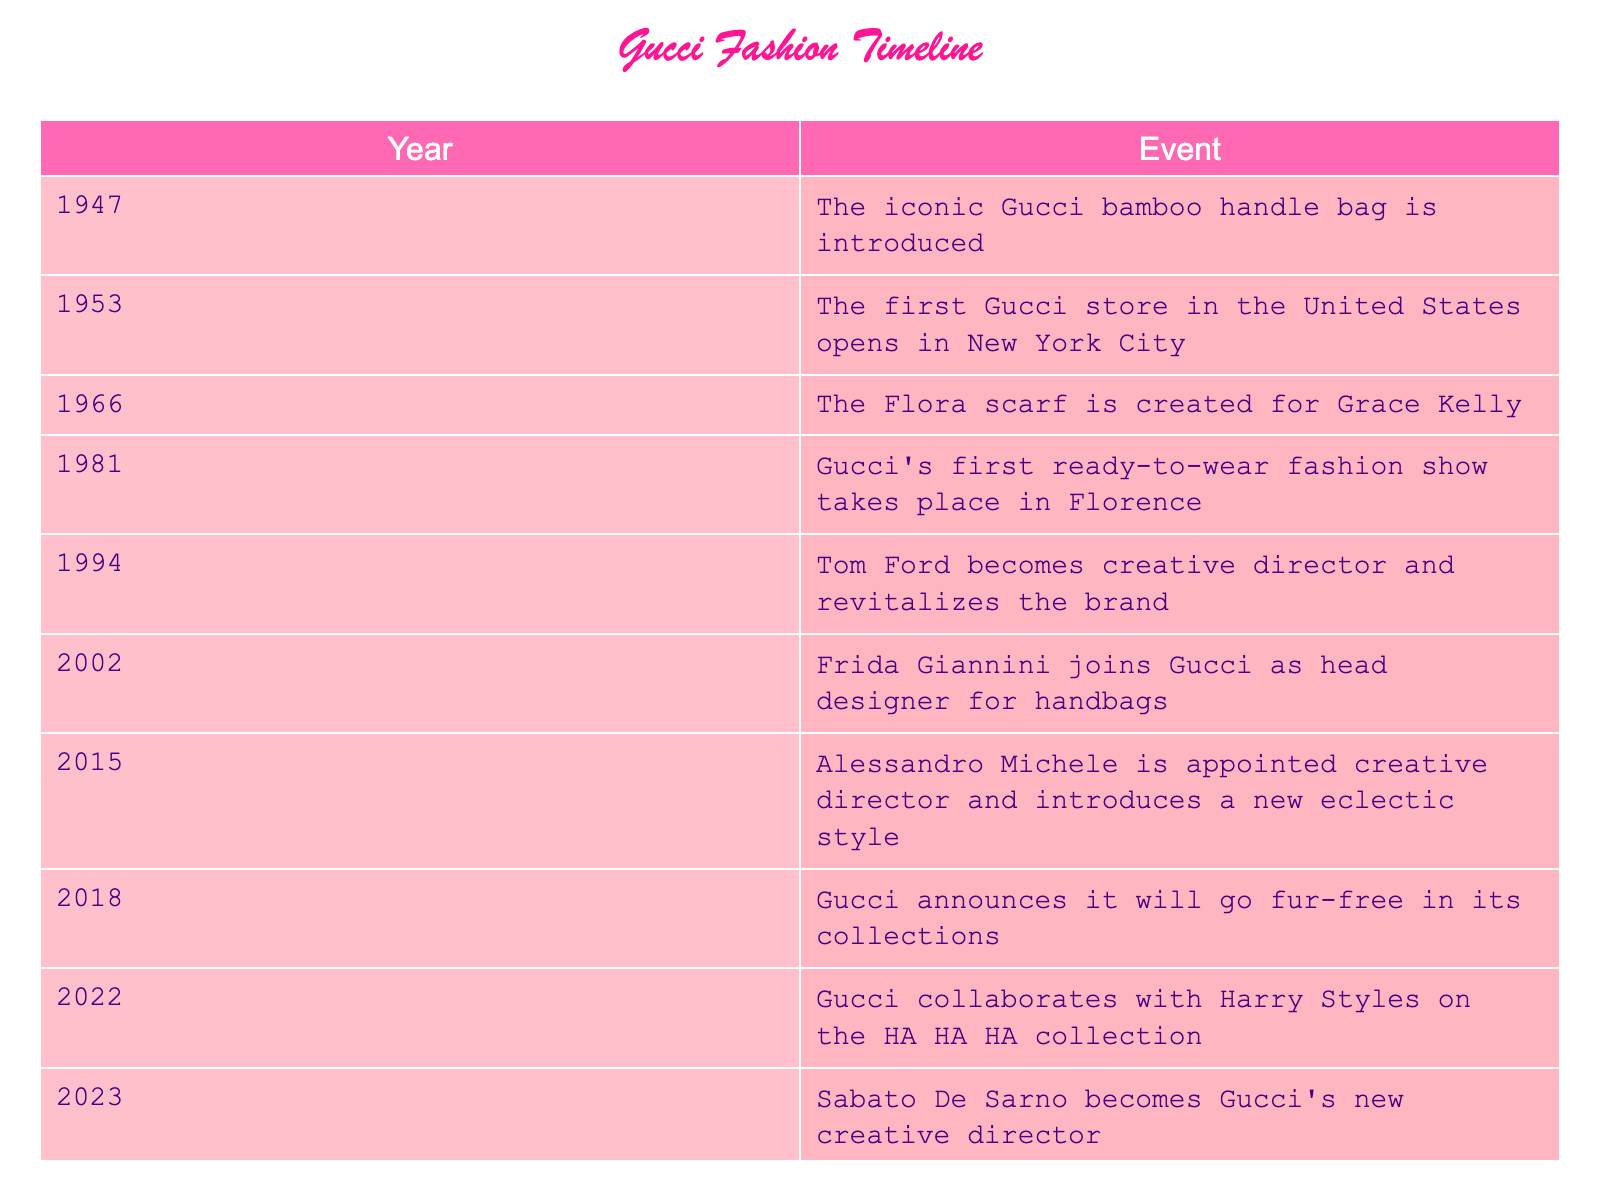What year was Gucci's first ready-to-wear fashion show? The table shows that Gucci's first ready-to-wear fashion show took place in 1981.
Answer: 1981 In which year did Alessandro Michele become Gucci's creative director? According to the table, Alessandro Michele was appointed as creative director in 2015.
Answer: 2015 Did Gucci announce it would go fur-free in 2018? The table indicates that in 2018, Gucci did announce that it would be fur-free in its collections, confirming the fact.
Answer: Yes What notable event happened in the year 1994? The table lists that in 1994, Tom Ford became the creative director and revitalized the brand, marking a significant milestone.
Answer: Tom Ford became creative director How many years passed between the introduction of the iconic bamboo handle bag and the appointment of Alessandro Michele as creative director? The iconic bamboo handle bag was introduced in 1947 and Alessandro Michele was appointed in 2015. The difference is 2015 - 1947 = 68 years.
Answer: 68 years What are the two milestones in the table that occurred in the 2000s? Reviewing the table, the two milestones from the 2000s are in 2002 when Frida Giannini joined as head designer for handbags and 2015 when Alessandro Michele became creative director.
Answer: 2002 and 2015 True or False: The collaboration with Harry Styles on the HA HA HA collection happened before Gucci announced it would go fur-free. The table shows that Gucci announced it would go fur-free in 2018 and collaborated with Harry Styles in 2022. Therefore, the collaboration occurred after the announcement.
Answer: False What significant change did Gucci make in 2018 regarding its product line? According to the table, in 2018, Gucci made the significant change to announce it would go fur-free in its collections.
Answer: Go fur-free Which event had the longest time span between it and the next major milestone? By looking at the table, the time span between 1981 (Gucci's first ready-to-wear fashion show) and 1994 (Tom Ford becomes creative director) is 13 years, which is longer than any other consecutive events listed.
Answer: 13 years 